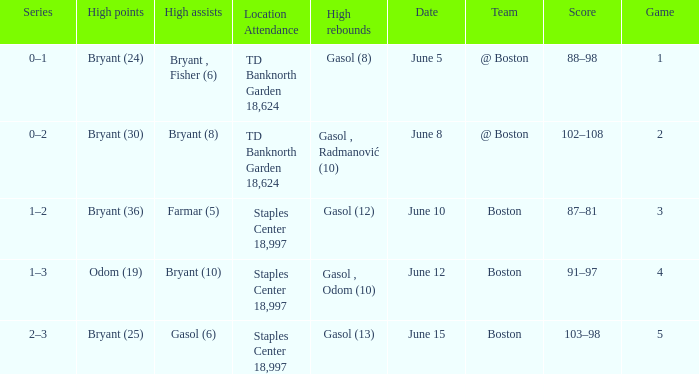Name the series on june 5 0–1. 